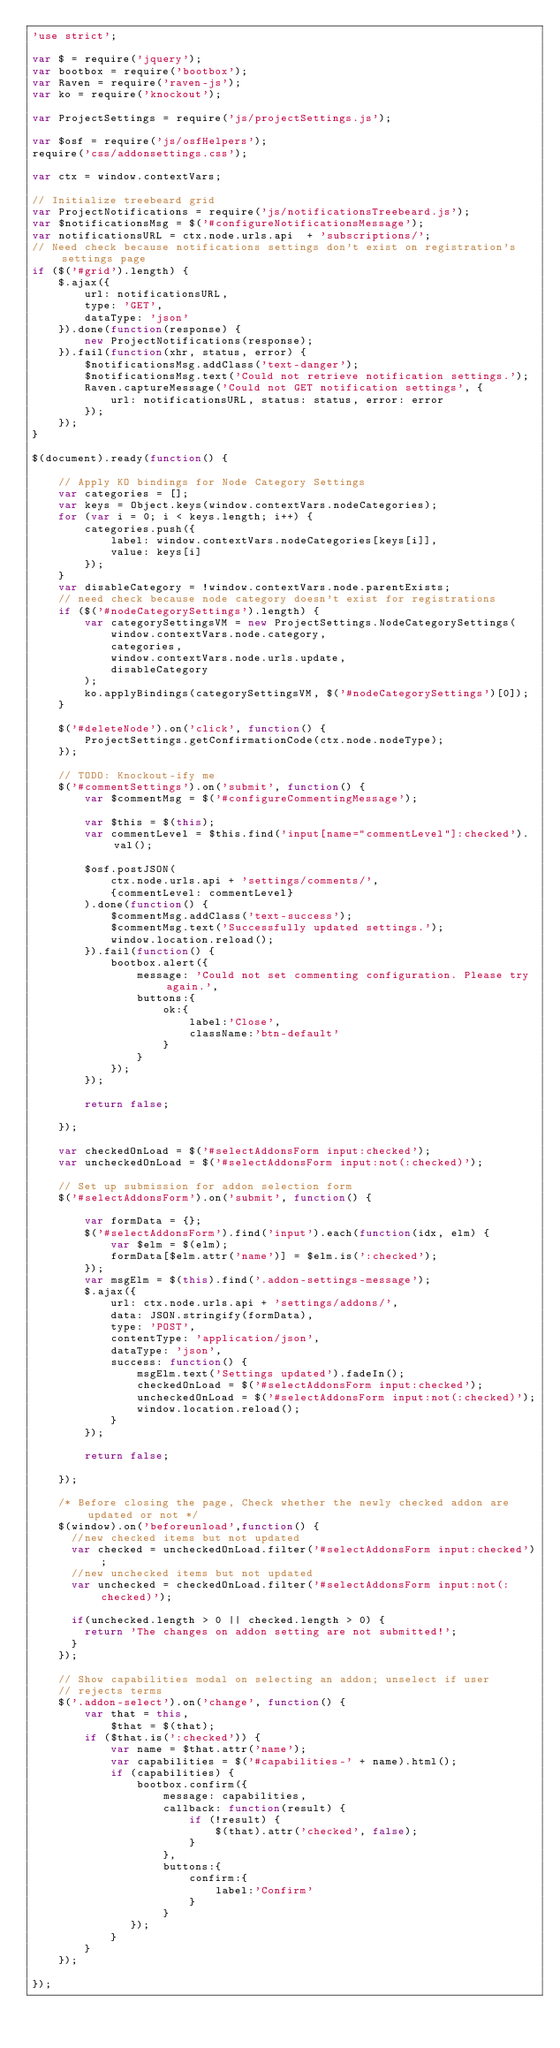<code> <loc_0><loc_0><loc_500><loc_500><_JavaScript_>'use strict';

var $ = require('jquery');
var bootbox = require('bootbox');
var Raven = require('raven-js');
var ko = require('knockout');

var ProjectSettings = require('js/projectSettings.js');

var $osf = require('js/osfHelpers');
require('css/addonsettings.css');

var ctx = window.contextVars;

// Initialize treebeard grid
var ProjectNotifications = require('js/notificationsTreebeard.js');
var $notificationsMsg = $('#configureNotificationsMessage');
var notificationsURL = ctx.node.urls.api  + 'subscriptions/';
// Need check because notifications settings don't exist on registration's settings page
if ($('#grid').length) {
    $.ajax({
        url: notificationsURL,
        type: 'GET',
        dataType: 'json'
    }).done(function(response) {
        new ProjectNotifications(response);
    }).fail(function(xhr, status, error) {
        $notificationsMsg.addClass('text-danger');
        $notificationsMsg.text('Could not retrieve notification settings.');
        Raven.captureMessage('Could not GET notification settings', {
            url: notificationsURL, status: status, error: error
        });
    });
}

$(document).ready(function() {

    // Apply KO bindings for Node Category Settings
    var categories = [];
    var keys = Object.keys(window.contextVars.nodeCategories);
    for (var i = 0; i < keys.length; i++) {
        categories.push({
            label: window.contextVars.nodeCategories[keys[i]],
            value: keys[i]
        });
    }
    var disableCategory = !window.contextVars.node.parentExists;
    // need check because node category doesn't exist for registrations
    if ($('#nodeCategorySettings').length) {
        var categorySettingsVM = new ProjectSettings.NodeCategorySettings(
            window.contextVars.node.category,
            categories,
            window.contextVars.node.urls.update,
            disableCategory
        );
        ko.applyBindings(categorySettingsVM, $('#nodeCategorySettings')[0]);
    }

    $('#deleteNode').on('click', function() {
        ProjectSettings.getConfirmationCode(ctx.node.nodeType);
    });

    // TODO: Knockout-ify me
    $('#commentSettings').on('submit', function() {
        var $commentMsg = $('#configureCommentingMessage');

        var $this = $(this);
        var commentLevel = $this.find('input[name="commentLevel"]:checked').val();

        $osf.postJSON(
            ctx.node.urls.api + 'settings/comments/',
            {commentLevel: commentLevel}
        ).done(function() {
            $commentMsg.addClass('text-success');
            $commentMsg.text('Successfully updated settings.');
            window.location.reload();
        }).fail(function() {
            bootbox.alert({
                message: 'Could not set commenting configuration. Please try again.',
                buttons:{
                    ok:{
                        label:'Close',
                        className:'btn-default'
                    }
                }
            });
        });

        return false;

    });

    var checkedOnLoad = $('#selectAddonsForm input:checked');
    var uncheckedOnLoad = $('#selectAddonsForm input:not(:checked)');

    // Set up submission for addon selection form
    $('#selectAddonsForm').on('submit', function() {

        var formData = {};
        $('#selectAddonsForm').find('input').each(function(idx, elm) {
            var $elm = $(elm);
            formData[$elm.attr('name')] = $elm.is(':checked');
        });
        var msgElm = $(this).find('.addon-settings-message');
        $.ajax({
            url: ctx.node.urls.api + 'settings/addons/',
            data: JSON.stringify(formData),
            type: 'POST',
            contentType: 'application/json',
            dataType: 'json',
            success: function() {
                msgElm.text('Settings updated').fadeIn();
                checkedOnLoad = $('#selectAddonsForm input:checked');
                uncheckedOnLoad = $('#selectAddonsForm input:not(:checked)');
                window.location.reload();
            }
        });

        return false;

    });

    /* Before closing the page, Check whether the newly checked addon are updated or not */
    $(window).on('beforeunload',function() {
      //new checked items but not updated
      var checked = uncheckedOnLoad.filter('#selectAddonsForm input:checked');
      //new unchecked items but not updated
      var unchecked = checkedOnLoad.filter('#selectAddonsForm input:not(:checked)');

      if(unchecked.length > 0 || checked.length > 0) {
        return 'The changes on addon setting are not submitted!';
      }
    });

    // Show capabilities modal on selecting an addon; unselect if user
    // rejects terms
    $('.addon-select').on('change', function() {
        var that = this,
            $that = $(that);
        if ($that.is(':checked')) {
            var name = $that.attr('name');
            var capabilities = $('#capabilities-' + name).html();
            if (capabilities) {
                bootbox.confirm({
                    message: capabilities,
                    callback: function(result) {
                        if (!result) {
                            $(that).attr('checked', false);
                        }
                    },
                    buttons:{
                        confirm:{
                            label:'Confirm'
                        }
                    }
               });
            }
        }
    });

});


</code> 